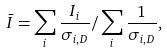Convert formula to latex. <formula><loc_0><loc_0><loc_500><loc_500>\bar { I } = \sum _ { i } \frac { I _ { i } } { \sigma _ { i , D } } / \sum _ { i } \frac { 1 } { \sigma _ { i , D } } ,</formula> 